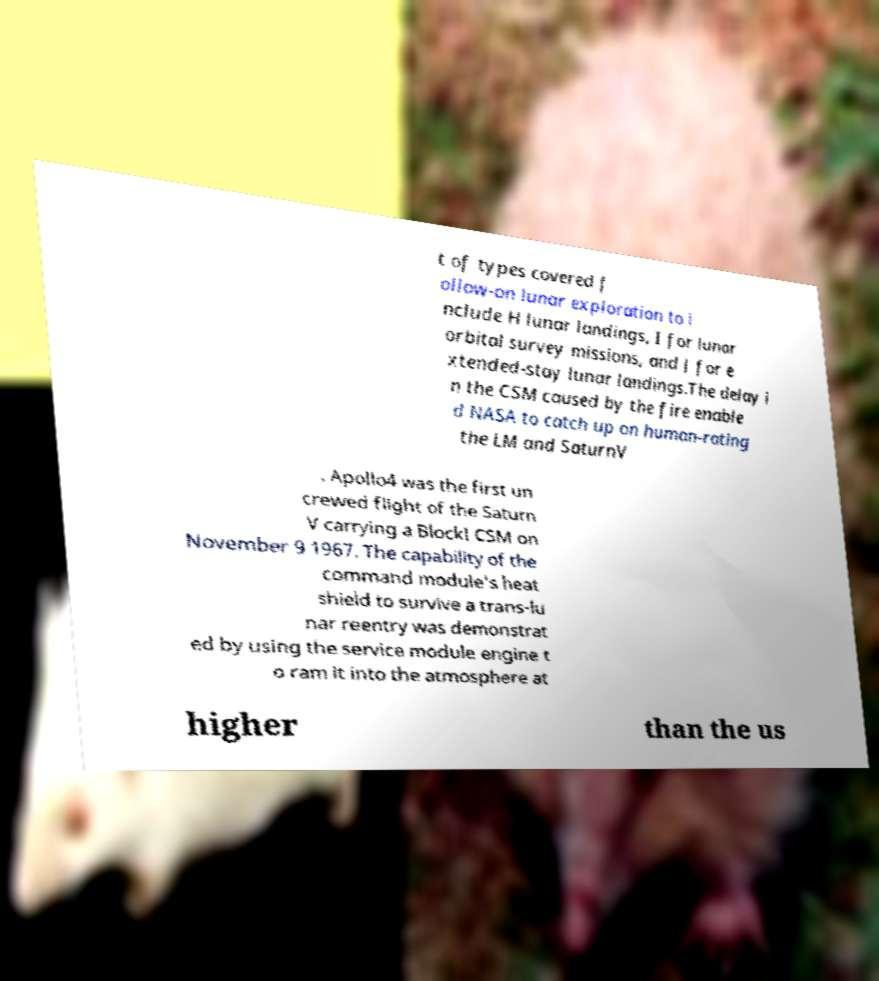Can you read and provide the text displayed in the image?This photo seems to have some interesting text. Can you extract and type it out for me? t of types covered f ollow-on lunar exploration to i nclude H lunar landings, I for lunar orbital survey missions, and J for e xtended-stay lunar landings.The delay i n the CSM caused by the fire enable d NASA to catch up on human-rating the LM and SaturnV . Apollo4 was the first un crewed flight of the Saturn V carrying a BlockI CSM on November 9 1967. The capability of the command module's heat shield to survive a trans-lu nar reentry was demonstrat ed by using the service module engine t o ram it into the atmosphere at higher than the us 